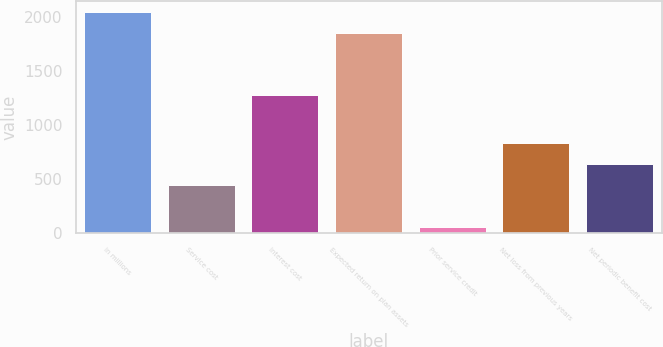<chart> <loc_0><loc_0><loc_500><loc_500><bar_chart><fcel>in millions<fcel>Service cost<fcel>Interest cost<fcel>Expected return on plan assets<fcel>Prior service credit<fcel>Net loss from previous years<fcel>Net periodic benefit cost<nl><fcel>2048.6<fcel>446<fcel>1284<fcel>1853<fcel>60<fcel>837.2<fcel>641.6<nl></chart> 